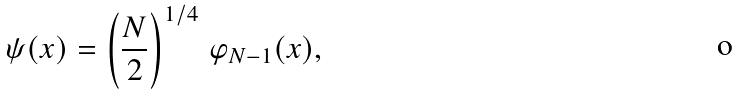<formula> <loc_0><loc_0><loc_500><loc_500>\psi ( x ) = \left ( \frac { N } { 2 } \right ) ^ { 1 / 4 } \, \varphi _ { N - 1 } ( x ) ,</formula> 